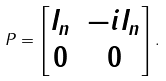<formula> <loc_0><loc_0><loc_500><loc_500>P = \begin{bmatrix} I _ { n } & - i I _ { n } \\ 0 & 0 \end{bmatrix} .</formula> 